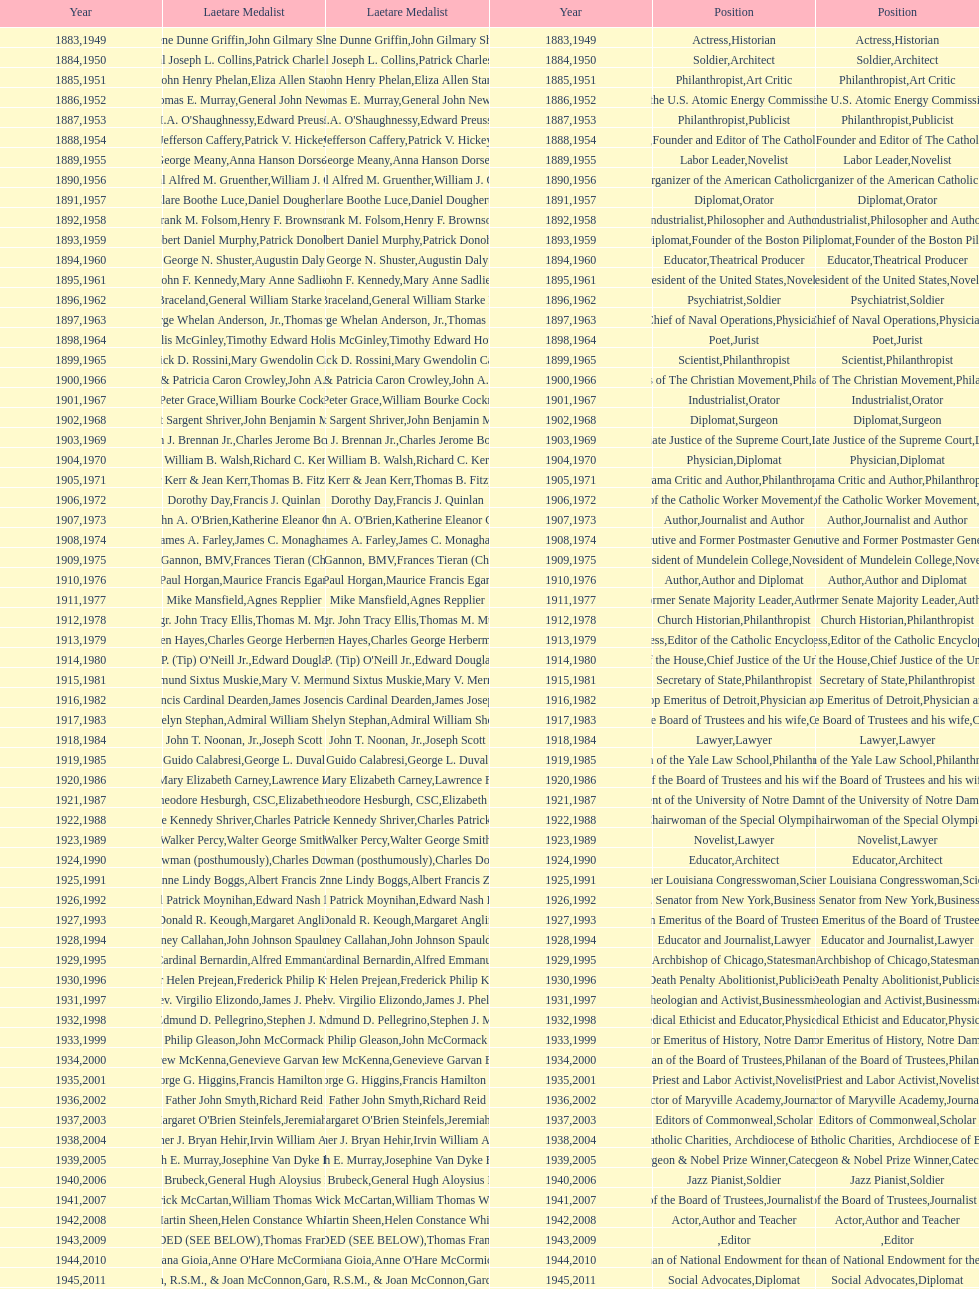What is the name of the laetare medalist listed before edward preuss? General John Newton. 